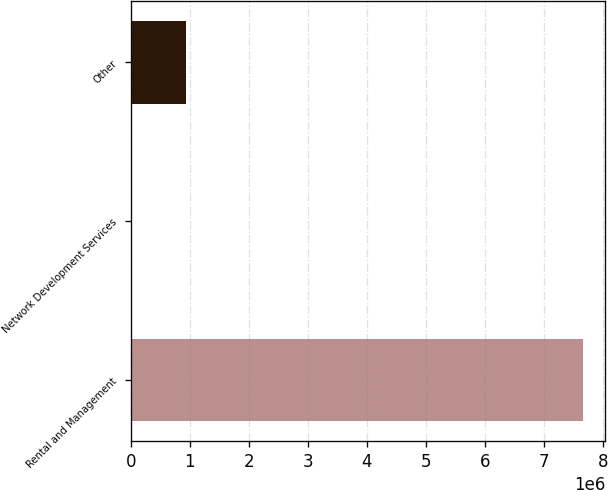<chart> <loc_0><loc_0><loc_500><loc_500><bar_chart><fcel>Rental and Management<fcel>Network Development Services<fcel>Other<nl><fcel>7.6557e+06<fcel>20670<fcel>936848<nl></chart> 